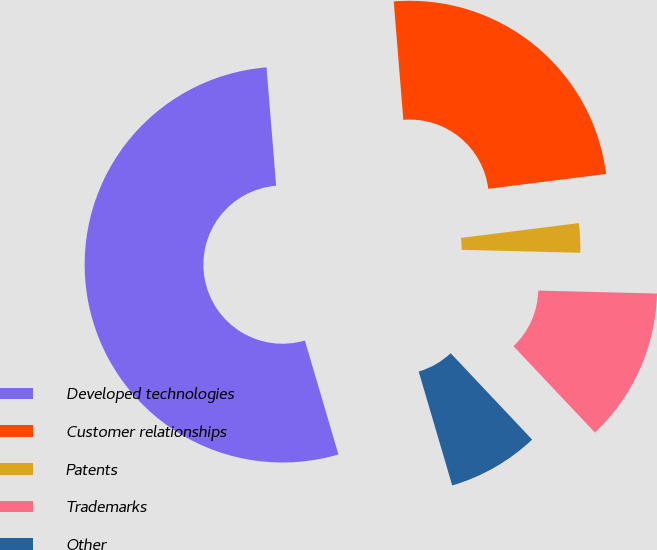<chart> <loc_0><loc_0><loc_500><loc_500><pie_chart><fcel>Developed technologies<fcel>Customer relationships<fcel>Patents<fcel>Trademarks<fcel>Other<nl><fcel>53.27%<fcel>24.3%<fcel>2.39%<fcel>12.57%<fcel>7.48%<nl></chart> 